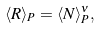Convert formula to latex. <formula><loc_0><loc_0><loc_500><loc_500>\langle R \rangle _ { P } = \langle N \rangle _ { P } ^ { \nu } ,</formula> 